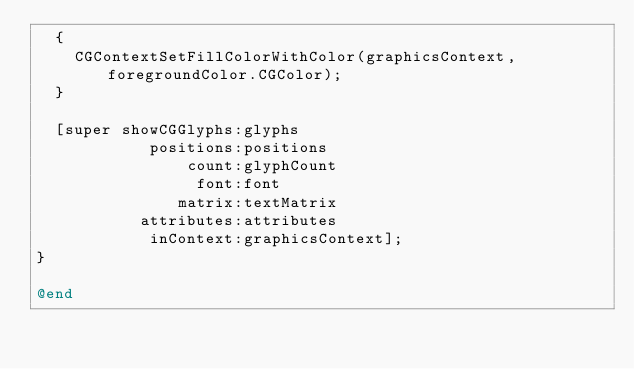Convert code to text. <code><loc_0><loc_0><loc_500><loc_500><_ObjectiveC_>  {
    CGContextSetFillColorWithColor(graphicsContext, foregroundColor.CGColor);
  }
  
  [super showCGGlyphs:glyphs
            positions:positions
                count:glyphCount
                 font:font
               matrix:textMatrix
           attributes:attributes
            inContext:graphicsContext];
}

@end
</code> 